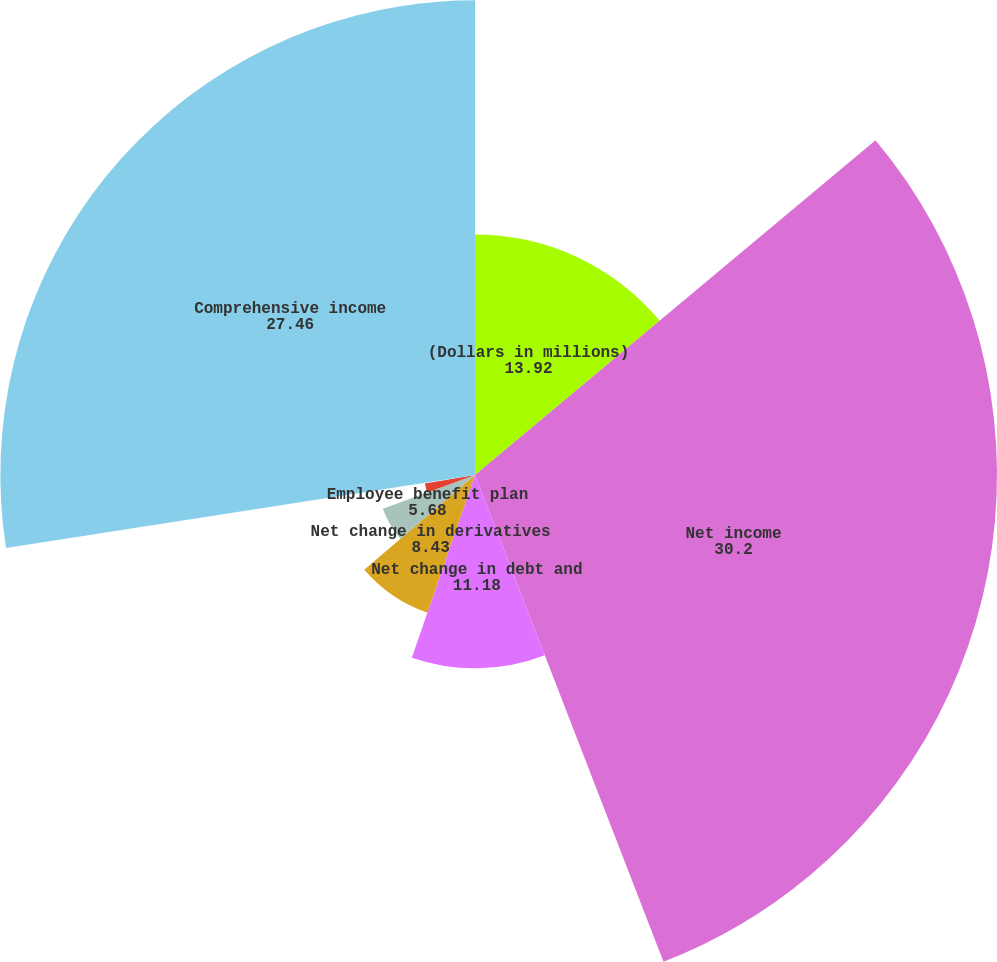<chart> <loc_0><loc_0><loc_500><loc_500><pie_chart><fcel>(Dollars in millions)<fcel>Net income<fcel>Net change in debt and<fcel>Net change in derivatives<fcel>Employee benefit plan<fcel>Net change in foreign currency<fcel>Other comprehensive income<fcel>Comprehensive income<nl><fcel>13.92%<fcel>30.2%<fcel>11.18%<fcel>8.43%<fcel>5.68%<fcel>2.94%<fcel>0.19%<fcel>27.46%<nl></chart> 